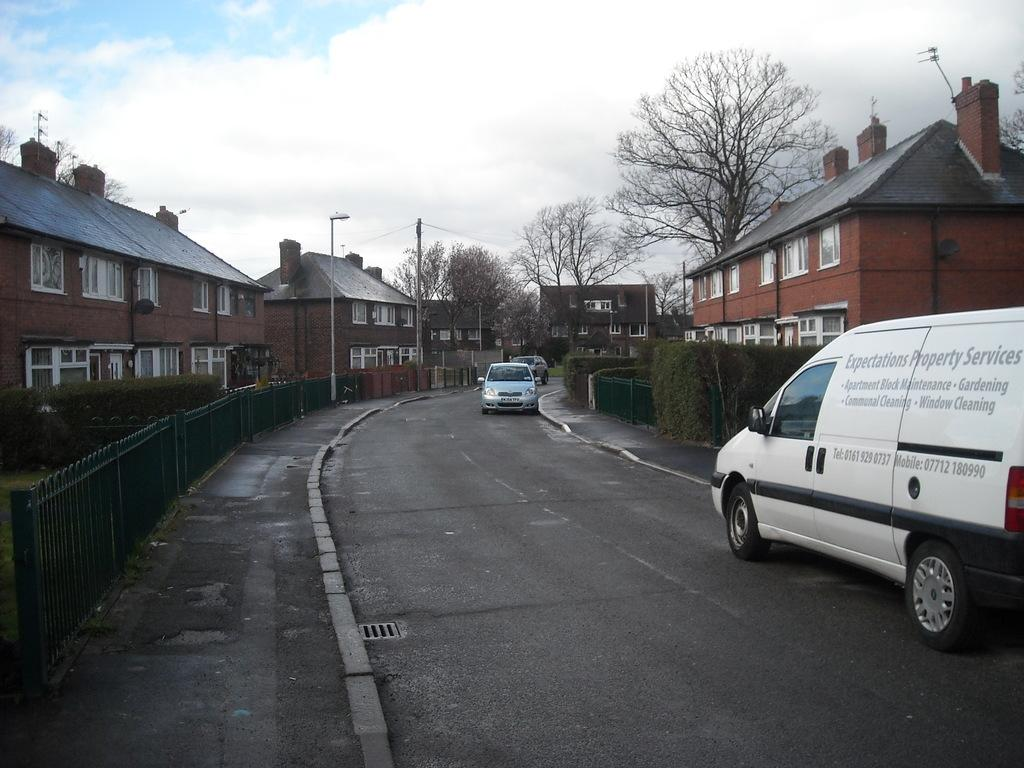<image>
Share a concise interpretation of the image provided. A white can has "expectations property services" written on the side 